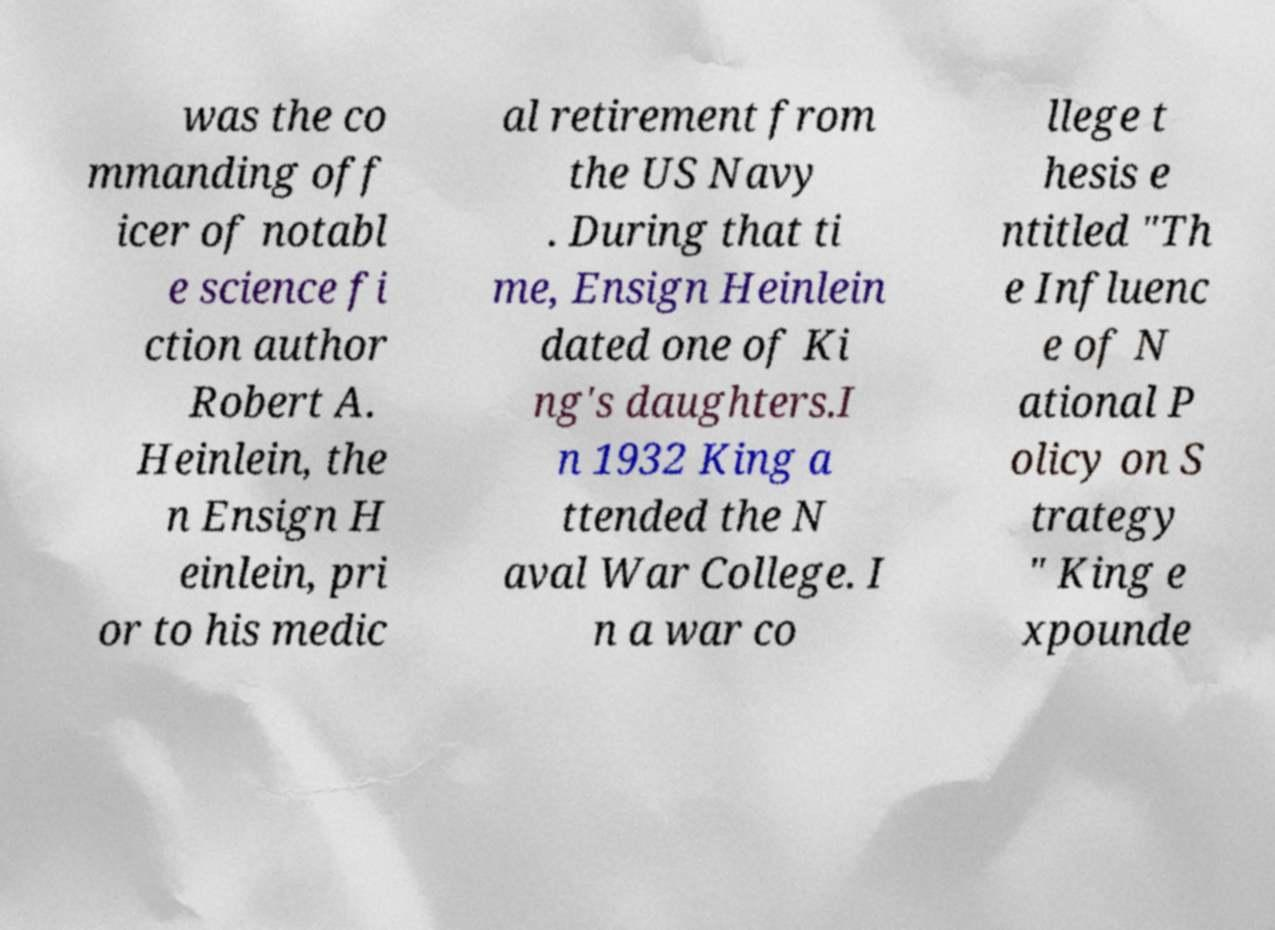What messages or text are displayed in this image? I need them in a readable, typed format. was the co mmanding off icer of notabl e science fi ction author Robert A. Heinlein, the n Ensign H einlein, pri or to his medic al retirement from the US Navy . During that ti me, Ensign Heinlein dated one of Ki ng's daughters.I n 1932 King a ttended the N aval War College. I n a war co llege t hesis e ntitled "Th e Influenc e of N ational P olicy on S trategy " King e xpounde 